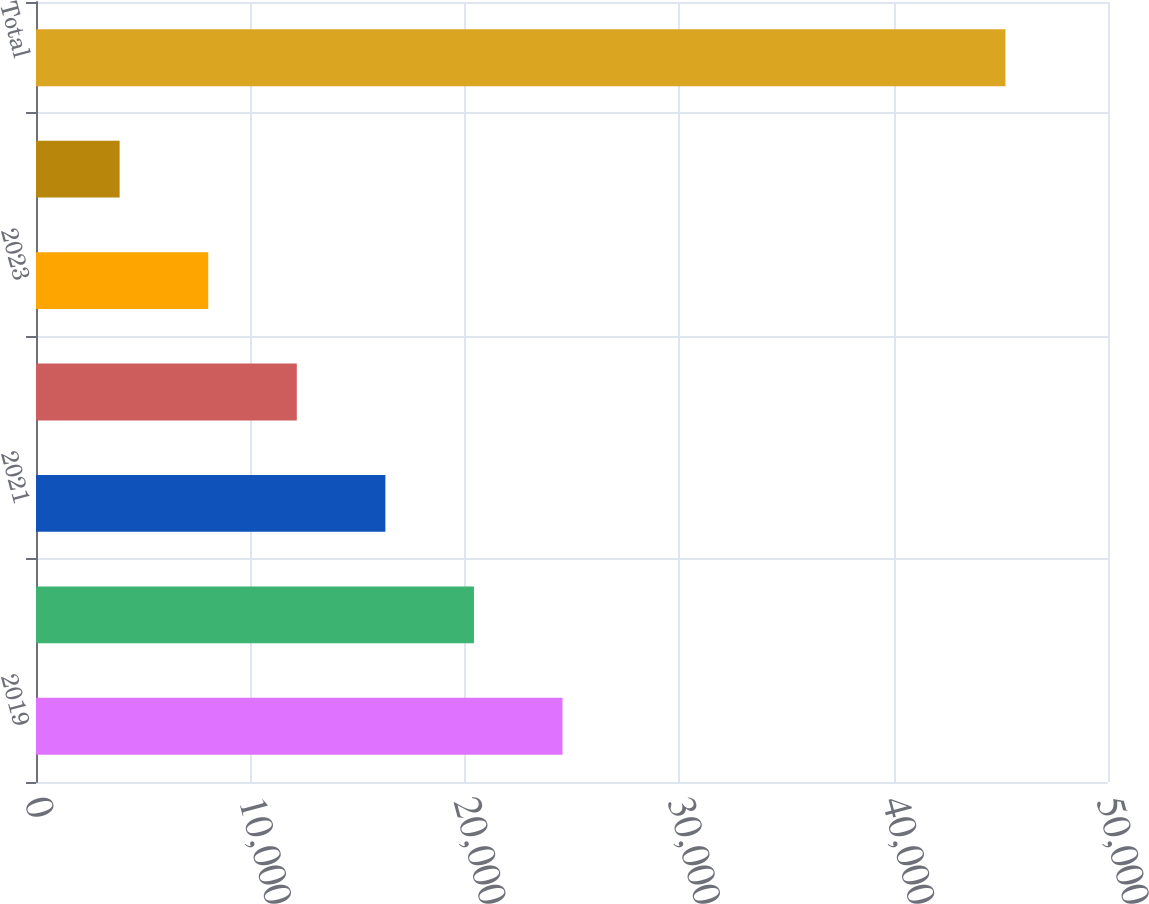<chart> <loc_0><loc_0><loc_500><loc_500><bar_chart><fcel>2019<fcel>2020<fcel>2021<fcel>2022<fcel>2023<fcel>2024 - thereafter<fcel>Total<nl><fcel>24558.5<fcel>20427<fcel>16295.5<fcel>12164<fcel>8032.5<fcel>3901<fcel>45216<nl></chart> 